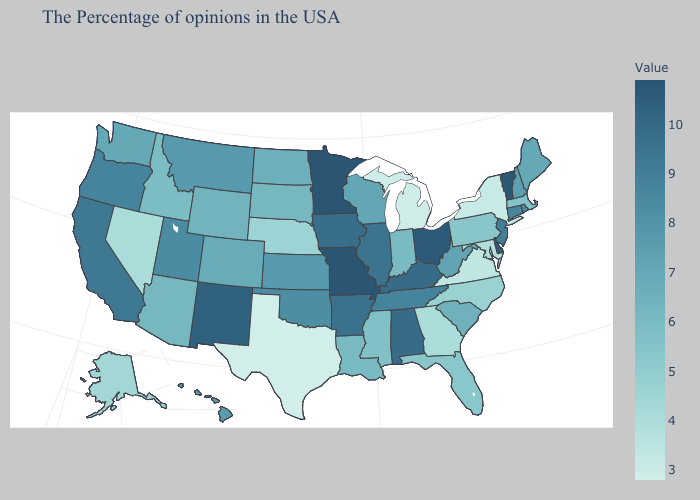Does Minnesota have the highest value in the USA?
Concise answer only. Yes. Which states have the lowest value in the South?
Keep it brief. Texas. Which states have the lowest value in the USA?
Be succinct. Texas. Does the map have missing data?
Concise answer only. No. Which states have the lowest value in the West?
Short answer required. Nevada. 